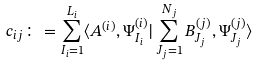<formula> <loc_0><loc_0><loc_500><loc_500>c _ { i j } \colon = \sum _ { I _ { i } = 1 } ^ { L _ { i } } \langle A ^ { ( i ) } , \Psi ^ { ( i ) } _ { I _ { i } } | \sum _ { J _ { j } = 1 } ^ { N _ { j } } B ^ { ( j ) } _ { J _ { j } } , \Psi ^ { ( j ) } _ { J _ { j } } \rangle</formula> 